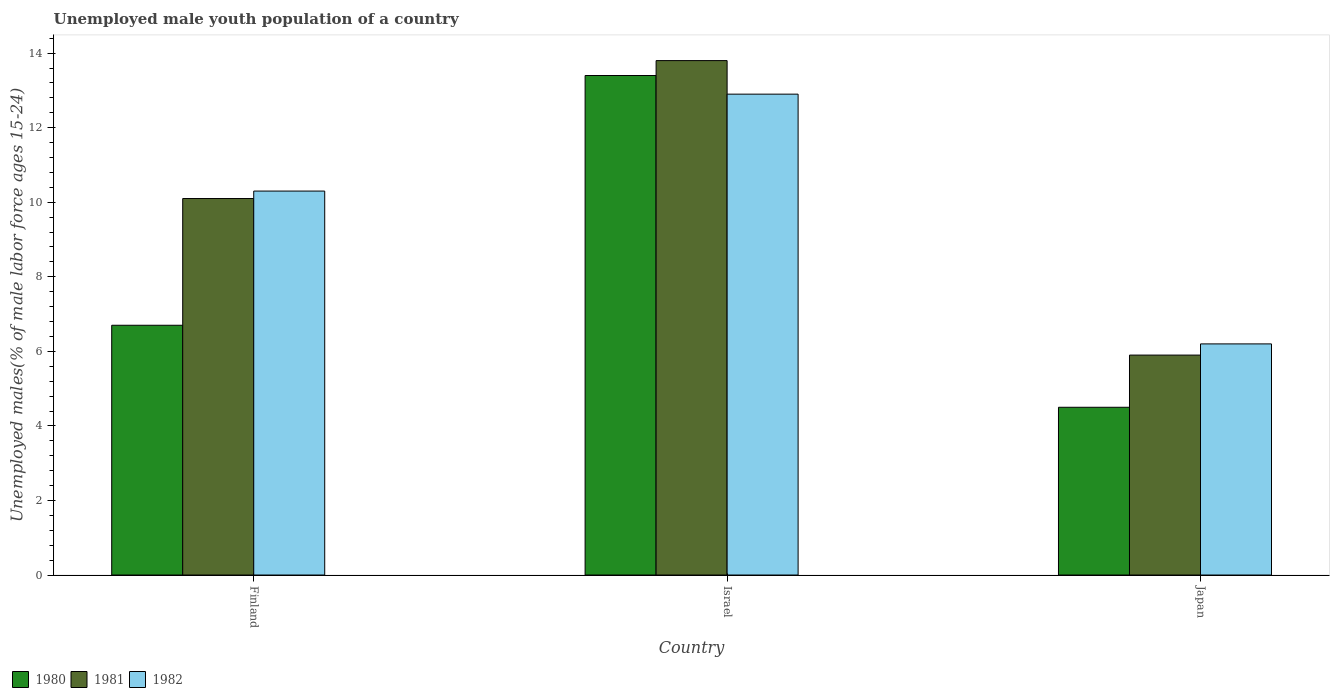How many different coloured bars are there?
Make the answer very short. 3. How many groups of bars are there?
Your answer should be compact. 3. How many bars are there on the 2nd tick from the left?
Your answer should be very brief. 3. What is the label of the 1st group of bars from the left?
Offer a terse response. Finland. In how many cases, is the number of bars for a given country not equal to the number of legend labels?
Provide a succinct answer. 0. What is the percentage of unemployed male youth population in 1982 in Japan?
Provide a succinct answer. 6.2. Across all countries, what is the maximum percentage of unemployed male youth population in 1982?
Give a very brief answer. 12.9. Across all countries, what is the minimum percentage of unemployed male youth population in 1981?
Your response must be concise. 5.9. In which country was the percentage of unemployed male youth population in 1980 minimum?
Provide a short and direct response. Japan. What is the total percentage of unemployed male youth population in 1981 in the graph?
Ensure brevity in your answer.  29.8. What is the difference between the percentage of unemployed male youth population in 1981 in Israel and that in Japan?
Your answer should be very brief. 7.9. What is the difference between the percentage of unemployed male youth population in 1980 in Israel and the percentage of unemployed male youth population in 1982 in Japan?
Provide a short and direct response. 7.2. What is the average percentage of unemployed male youth population in 1982 per country?
Provide a short and direct response. 9.8. What is the difference between the percentage of unemployed male youth population of/in 1980 and percentage of unemployed male youth population of/in 1982 in Finland?
Ensure brevity in your answer.  -3.6. In how many countries, is the percentage of unemployed male youth population in 1982 greater than 4.8 %?
Your answer should be very brief. 3. What is the ratio of the percentage of unemployed male youth population in 1980 in Finland to that in Israel?
Offer a terse response. 0.5. Is the difference between the percentage of unemployed male youth population in 1980 in Finland and Israel greater than the difference between the percentage of unemployed male youth population in 1982 in Finland and Israel?
Your answer should be compact. No. What is the difference between the highest and the second highest percentage of unemployed male youth population in 1980?
Make the answer very short. -8.9. What is the difference between the highest and the lowest percentage of unemployed male youth population in 1982?
Provide a succinct answer. 6.7. What does the 2nd bar from the left in Israel represents?
Give a very brief answer. 1981. How many bars are there?
Provide a succinct answer. 9. Are all the bars in the graph horizontal?
Offer a very short reply. No. Does the graph contain any zero values?
Provide a short and direct response. No. Does the graph contain grids?
Your response must be concise. No. How many legend labels are there?
Provide a short and direct response. 3. What is the title of the graph?
Offer a terse response. Unemployed male youth population of a country. Does "1988" appear as one of the legend labels in the graph?
Your answer should be very brief. No. What is the label or title of the Y-axis?
Your response must be concise. Unemployed males(% of male labor force ages 15-24). What is the Unemployed males(% of male labor force ages 15-24) of 1980 in Finland?
Offer a very short reply. 6.7. What is the Unemployed males(% of male labor force ages 15-24) of 1981 in Finland?
Give a very brief answer. 10.1. What is the Unemployed males(% of male labor force ages 15-24) of 1982 in Finland?
Offer a terse response. 10.3. What is the Unemployed males(% of male labor force ages 15-24) of 1980 in Israel?
Your answer should be very brief. 13.4. What is the Unemployed males(% of male labor force ages 15-24) of 1981 in Israel?
Give a very brief answer. 13.8. What is the Unemployed males(% of male labor force ages 15-24) of 1982 in Israel?
Your response must be concise. 12.9. What is the Unemployed males(% of male labor force ages 15-24) in 1980 in Japan?
Offer a very short reply. 4.5. What is the Unemployed males(% of male labor force ages 15-24) in 1981 in Japan?
Make the answer very short. 5.9. What is the Unemployed males(% of male labor force ages 15-24) in 1982 in Japan?
Keep it short and to the point. 6.2. Across all countries, what is the maximum Unemployed males(% of male labor force ages 15-24) in 1980?
Your answer should be very brief. 13.4. Across all countries, what is the maximum Unemployed males(% of male labor force ages 15-24) in 1981?
Offer a very short reply. 13.8. Across all countries, what is the maximum Unemployed males(% of male labor force ages 15-24) of 1982?
Give a very brief answer. 12.9. Across all countries, what is the minimum Unemployed males(% of male labor force ages 15-24) of 1981?
Offer a very short reply. 5.9. Across all countries, what is the minimum Unemployed males(% of male labor force ages 15-24) of 1982?
Your answer should be compact. 6.2. What is the total Unemployed males(% of male labor force ages 15-24) of 1980 in the graph?
Offer a very short reply. 24.6. What is the total Unemployed males(% of male labor force ages 15-24) of 1981 in the graph?
Your response must be concise. 29.8. What is the total Unemployed males(% of male labor force ages 15-24) in 1982 in the graph?
Your response must be concise. 29.4. What is the difference between the Unemployed males(% of male labor force ages 15-24) of 1980 in Finland and that in Israel?
Your response must be concise. -6.7. What is the difference between the Unemployed males(% of male labor force ages 15-24) of 1981 in Finland and that in Israel?
Provide a short and direct response. -3.7. What is the difference between the Unemployed males(% of male labor force ages 15-24) of 1981 in Israel and that in Japan?
Ensure brevity in your answer.  7.9. What is the difference between the Unemployed males(% of male labor force ages 15-24) of 1982 in Israel and that in Japan?
Give a very brief answer. 6.7. What is the difference between the Unemployed males(% of male labor force ages 15-24) in 1981 in Finland and the Unemployed males(% of male labor force ages 15-24) in 1982 in Israel?
Keep it short and to the point. -2.8. What is the difference between the Unemployed males(% of male labor force ages 15-24) of 1980 in Finland and the Unemployed males(% of male labor force ages 15-24) of 1981 in Japan?
Your answer should be very brief. 0.8. What is the difference between the Unemployed males(% of male labor force ages 15-24) in 1980 in Finland and the Unemployed males(% of male labor force ages 15-24) in 1982 in Japan?
Your answer should be very brief. 0.5. What is the difference between the Unemployed males(% of male labor force ages 15-24) in 1981 in Finland and the Unemployed males(% of male labor force ages 15-24) in 1982 in Japan?
Ensure brevity in your answer.  3.9. What is the average Unemployed males(% of male labor force ages 15-24) in 1980 per country?
Ensure brevity in your answer.  8.2. What is the average Unemployed males(% of male labor force ages 15-24) in 1981 per country?
Your response must be concise. 9.93. What is the difference between the Unemployed males(% of male labor force ages 15-24) in 1980 and Unemployed males(% of male labor force ages 15-24) in 1982 in Finland?
Your answer should be very brief. -3.6. What is the difference between the Unemployed males(% of male labor force ages 15-24) in 1981 and Unemployed males(% of male labor force ages 15-24) in 1982 in Finland?
Provide a succinct answer. -0.2. What is the difference between the Unemployed males(% of male labor force ages 15-24) in 1980 and Unemployed males(% of male labor force ages 15-24) in 1982 in Israel?
Provide a short and direct response. 0.5. What is the difference between the Unemployed males(% of male labor force ages 15-24) in 1980 and Unemployed males(% of male labor force ages 15-24) in 1982 in Japan?
Your response must be concise. -1.7. What is the ratio of the Unemployed males(% of male labor force ages 15-24) of 1980 in Finland to that in Israel?
Your response must be concise. 0.5. What is the ratio of the Unemployed males(% of male labor force ages 15-24) of 1981 in Finland to that in Israel?
Offer a terse response. 0.73. What is the ratio of the Unemployed males(% of male labor force ages 15-24) in 1982 in Finland to that in Israel?
Keep it short and to the point. 0.8. What is the ratio of the Unemployed males(% of male labor force ages 15-24) of 1980 in Finland to that in Japan?
Your answer should be compact. 1.49. What is the ratio of the Unemployed males(% of male labor force ages 15-24) in 1981 in Finland to that in Japan?
Offer a very short reply. 1.71. What is the ratio of the Unemployed males(% of male labor force ages 15-24) of 1982 in Finland to that in Japan?
Ensure brevity in your answer.  1.66. What is the ratio of the Unemployed males(% of male labor force ages 15-24) of 1980 in Israel to that in Japan?
Offer a very short reply. 2.98. What is the ratio of the Unemployed males(% of male labor force ages 15-24) in 1981 in Israel to that in Japan?
Make the answer very short. 2.34. What is the ratio of the Unemployed males(% of male labor force ages 15-24) of 1982 in Israel to that in Japan?
Offer a very short reply. 2.08. What is the difference between the highest and the second highest Unemployed males(% of male labor force ages 15-24) of 1980?
Offer a very short reply. 6.7. What is the difference between the highest and the second highest Unemployed males(% of male labor force ages 15-24) in 1982?
Provide a succinct answer. 2.6. What is the difference between the highest and the lowest Unemployed males(% of male labor force ages 15-24) in 1980?
Give a very brief answer. 8.9. What is the difference between the highest and the lowest Unemployed males(% of male labor force ages 15-24) in 1981?
Your response must be concise. 7.9. What is the difference between the highest and the lowest Unemployed males(% of male labor force ages 15-24) of 1982?
Ensure brevity in your answer.  6.7. 